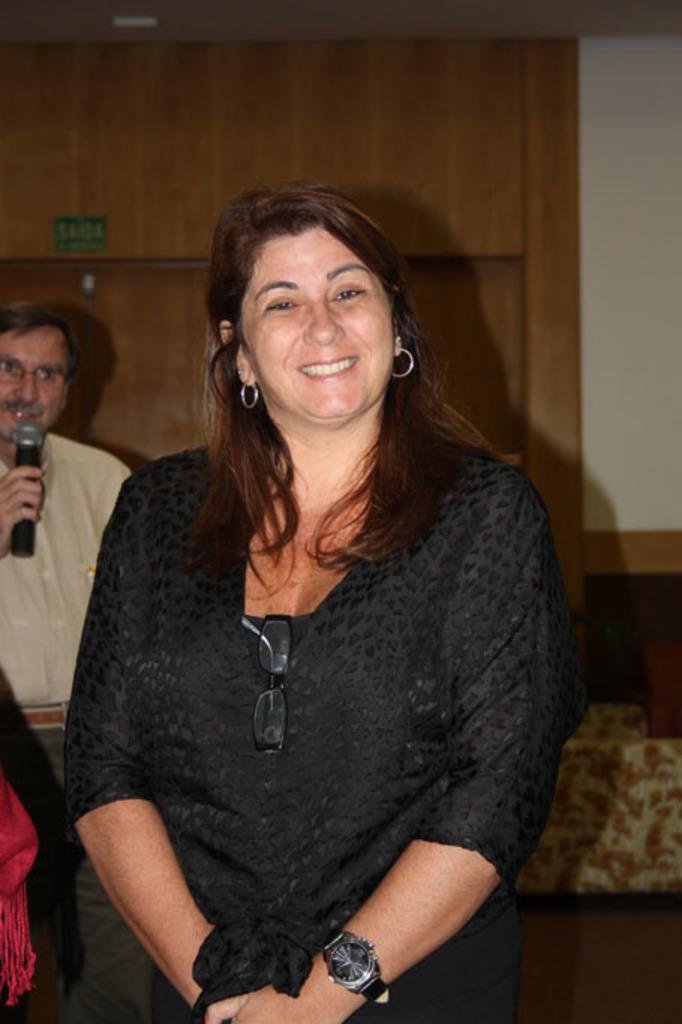Can you describe this image briefly? In this image we can see few persons. In the background, we can see a person holding a mic. Behind the persons we can see a wall. 